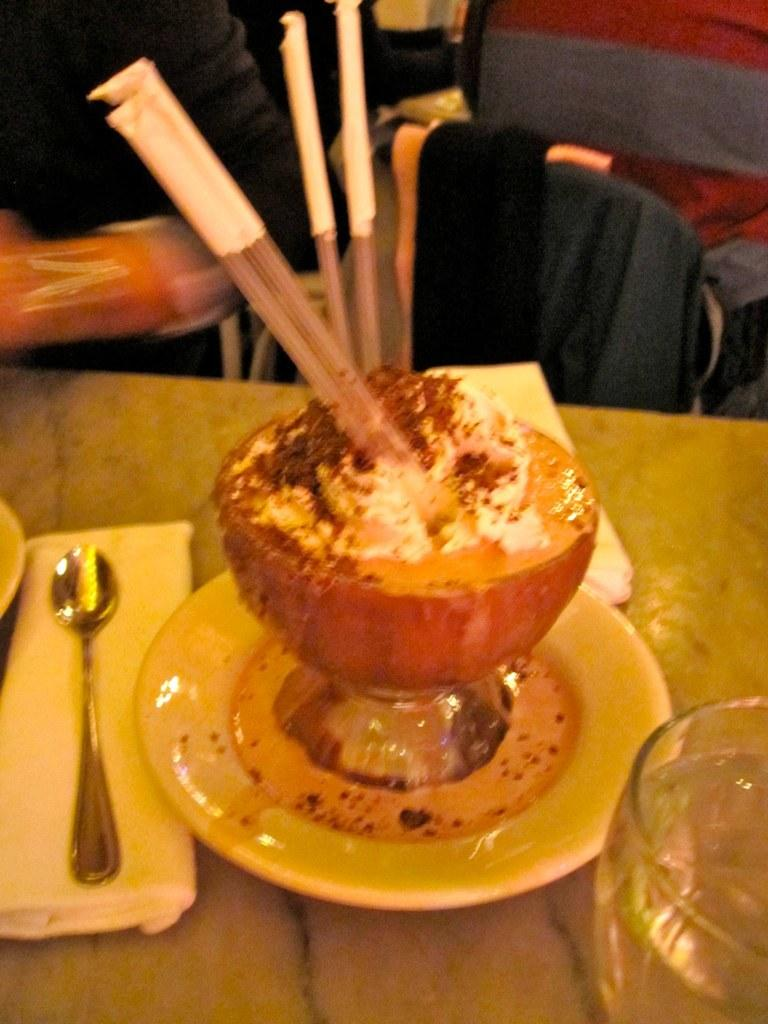What is on the plate that is visible in the image? There is no information about what is on the plate in the provided facts. What is the utensil visible in the image? There is a spoon in the image. What is in the bowl that is visible in the image? There is a bowl of ice cream in the image. Where are the plate, spoon, and bowl of ice cream located in the image? The plate, spoon, and bowl of ice cream are on a table in the image. What type of rock can be seen in the image? There is no rock present in the image. What kind of lumber is used to construct the table in the image? The provided facts do not mention the type of lumber used to construct the table. Can you describe the curve of the spoon in the image? The provided facts do not mention the shape of the spoon, so it is impossible to describe any curves. 